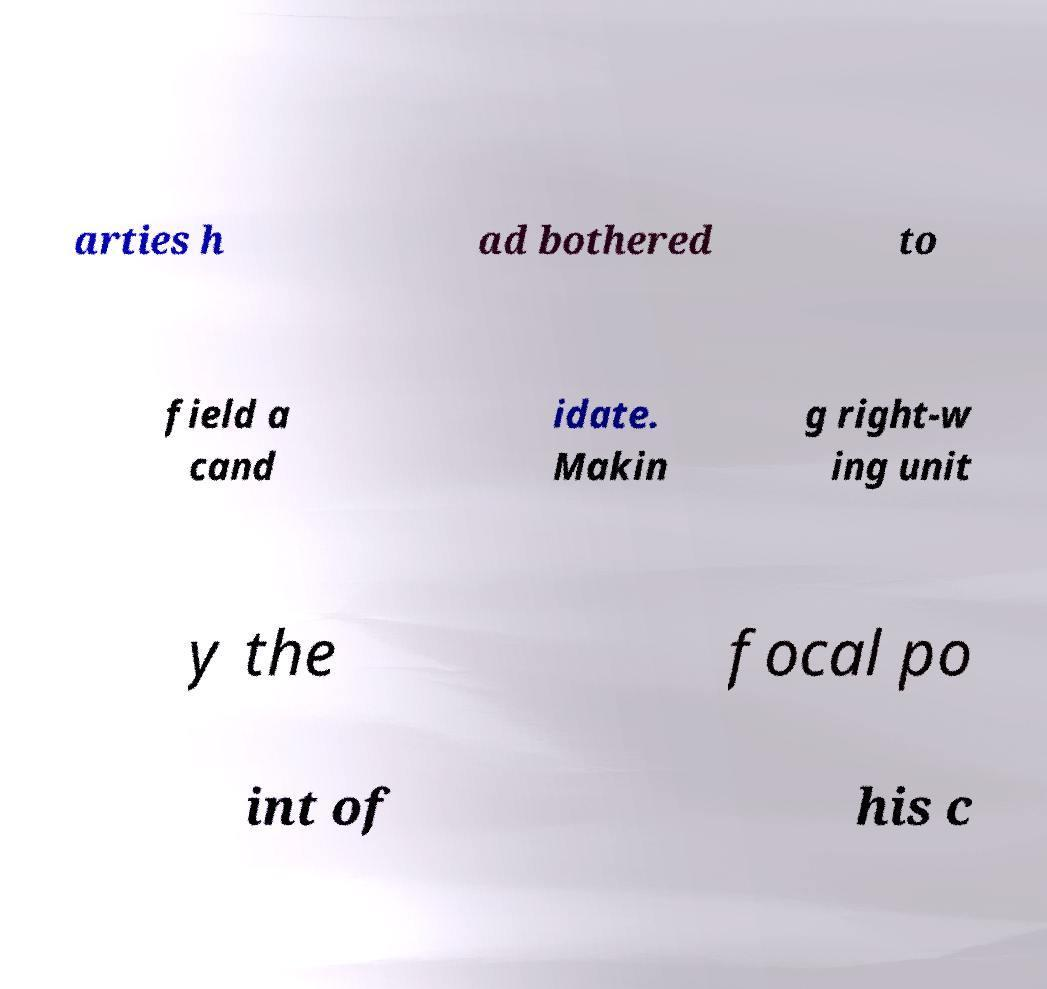Could you extract and type out the text from this image? arties h ad bothered to field a cand idate. Makin g right-w ing unit y the focal po int of his c 